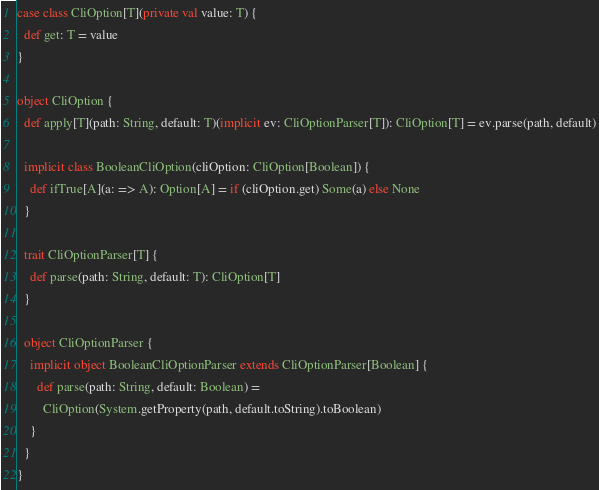Convert code to text. <code><loc_0><loc_0><loc_500><loc_500><_Scala_>case class CliOption[T](private val value: T) {
  def get: T = value
}

object CliOption {
  def apply[T](path: String, default: T)(implicit ev: CliOptionParser[T]): CliOption[T] = ev.parse(path, default)

  implicit class BooleanCliOption(cliOption: CliOption[Boolean]) {
    def ifTrue[A](a: => A): Option[A] = if (cliOption.get) Some(a) else None
  }

  trait CliOptionParser[T] {
    def parse(path: String, default: T): CliOption[T]
  }

  object CliOptionParser {
    implicit object BooleanCliOptionParser extends CliOptionParser[Boolean] {
      def parse(path: String, default: Boolean) =
        CliOption(System.getProperty(path, default.toString).toBoolean)
    }
  }
}
</code> 